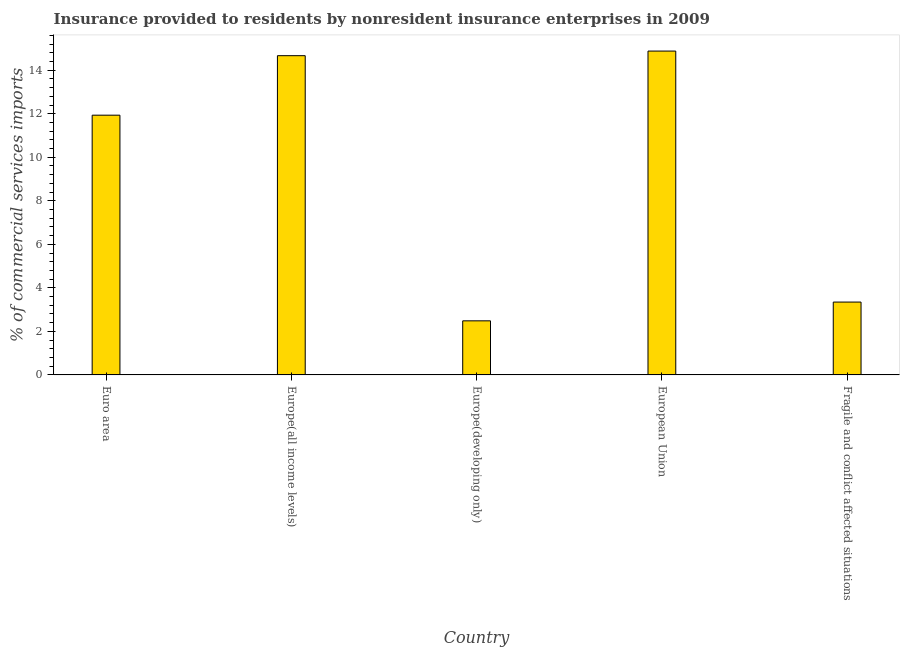Does the graph contain any zero values?
Offer a terse response. No. What is the title of the graph?
Provide a short and direct response. Insurance provided to residents by nonresident insurance enterprises in 2009. What is the label or title of the Y-axis?
Offer a terse response. % of commercial services imports. What is the insurance provided by non-residents in Europe(developing only)?
Make the answer very short. 2.48. Across all countries, what is the maximum insurance provided by non-residents?
Offer a terse response. 14.88. Across all countries, what is the minimum insurance provided by non-residents?
Give a very brief answer. 2.48. In which country was the insurance provided by non-residents maximum?
Keep it short and to the point. European Union. In which country was the insurance provided by non-residents minimum?
Provide a succinct answer. Europe(developing only). What is the sum of the insurance provided by non-residents?
Your answer should be very brief. 47.31. What is the difference between the insurance provided by non-residents in Europe(developing only) and Fragile and conflict affected situations?
Provide a short and direct response. -0.86. What is the average insurance provided by non-residents per country?
Make the answer very short. 9.46. What is the median insurance provided by non-residents?
Provide a succinct answer. 11.93. In how many countries, is the insurance provided by non-residents greater than 3.2 %?
Provide a short and direct response. 4. What is the ratio of the insurance provided by non-residents in European Union to that in Fragile and conflict affected situations?
Provide a short and direct response. 4.45. Is the difference between the insurance provided by non-residents in Europe(all income levels) and Europe(developing only) greater than the difference between any two countries?
Your answer should be very brief. No. What is the difference between the highest and the second highest insurance provided by non-residents?
Your answer should be very brief. 0.21. What is the difference between the highest and the lowest insurance provided by non-residents?
Your answer should be very brief. 12.39. In how many countries, is the insurance provided by non-residents greater than the average insurance provided by non-residents taken over all countries?
Offer a very short reply. 3. How many bars are there?
Ensure brevity in your answer.  5. How many countries are there in the graph?
Make the answer very short. 5. Are the values on the major ticks of Y-axis written in scientific E-notation?
Give a very brief answer. No. What is the % of commercial services imports of Euro area?
Offer a terse response. 11.93. What is the % of commercial services imports of Europe(all income levels)?
Keep it short and to the point. 14.67. What is the % of commercial services imports in Europe(developing only)?
Provide a succinct answer. 2.48. What is the % of commercial services imports in European Union?
Offer a terse response. 14.88. What is the % of commercial services imports of Fragile and conflict affected situations?
Your answer should be compact. 3.35. What is the difference between the % of commercial services imports in Euro area and Europe(all income levels)?
Your answer should be compact. -2.73. What is the difference between the % of commercial services imports in Euro area and Europe(developing only)?
Ensure brevity in your answer.  9.45. What is the difference between the % of commercial services imports in Euro area and European Union?
Give a very brief answer. -2.95. What is the difference between the % of commercial services imports in Euro area and Fragile and conflict affected situations?
Ensure brevity in your answer.  8.59. What is the difference between the % of commercial services imports in Europe(all income levels) and Europe(developing only)?
Provide a short and direct response. 12.18. What is the difference between the % of commercial services imports in Europe(all income levels) and European Union?
Offer a very short reply. -0.21. What is the difference between the % of commercial services imports in Europe(all income levels) and Fragile and conflict affected situations?
Your answer should be compact. 11.32. What is the difference between the % of commercial services imports in Europe(developing only) and European Union?
Make the answer very short. -12.39. What is the difference between the % of commercial services imports in Europe(developing only) and Fragile and conflict affected situations?
Provide a short and direct response. -0.86. What is the difference between the % of commercial services imports in European Union and Fragile and conflict affected situations?
Ensure brevity in your answer.  11.53. What is the ratio of the % of commercial services imports in Euro area to that in Europe(all income levels)?
Make the answer very short. 0.81. What is the ratio of the % of commercial services imports in Euro area to that in Europe(developing only)?
Offer a terse response. 4.8. What is the ratio of the % of commercial services imports in Euro area to that in European Union?
Provide a short and direct response. 0.8. What is the ratio of the % of commercial services imports in Euro area to that in Fragile and conflict affected situations?
Offer a terse response. 3.56. What is the ratio of the % of commercial services imports in Europe(all income levels) to that in Europe(developing only)?
Give a very brief answer. 5.9. What is the ratio of the % of commercial services imports in Europe(all income levels) to that in Fragile and conflict affected situations?
Give a very brief answer. 4.38. What is the ratio of the % of commercial services imports in Europe(developing only) to that in European Union?
Your answer should be very brief. 0.17. What is the ratio of the % of commercial services imports in Europe(developing only) to that in Fragile and conflict affected situations?
Your answer should be very brief. 0.74. What is the ratio of the % of commercial services imports in European Union to that in Fragile and conflict affected situations?
Ensure brevity in your answer.  4.45. 